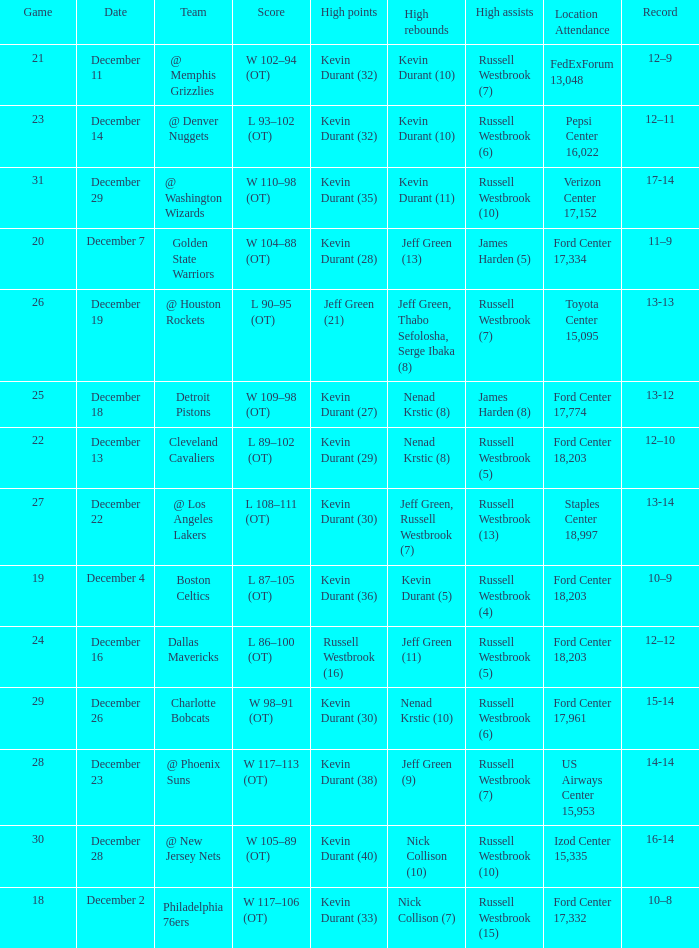Who has high points when verizon center 17,152 is location attendance? Kevin Durant (35). 